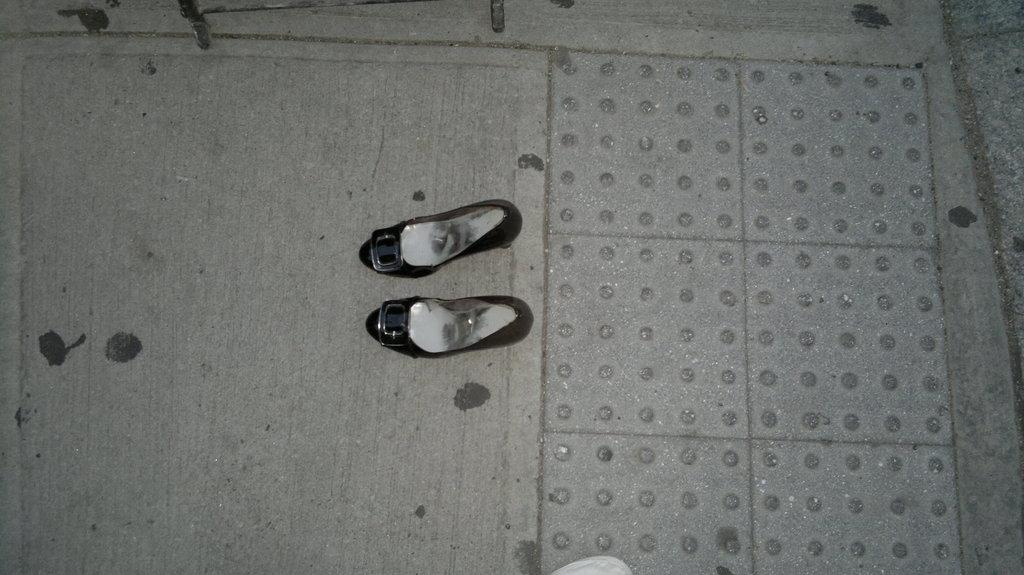What type of footwear is visible in the image? There are two black color shoes in the image. Where are the shoes located? The shoes are on the floor. What type of drain is visible in the image? There is no drain present in the image; it only features two black color shoes on the floor. 